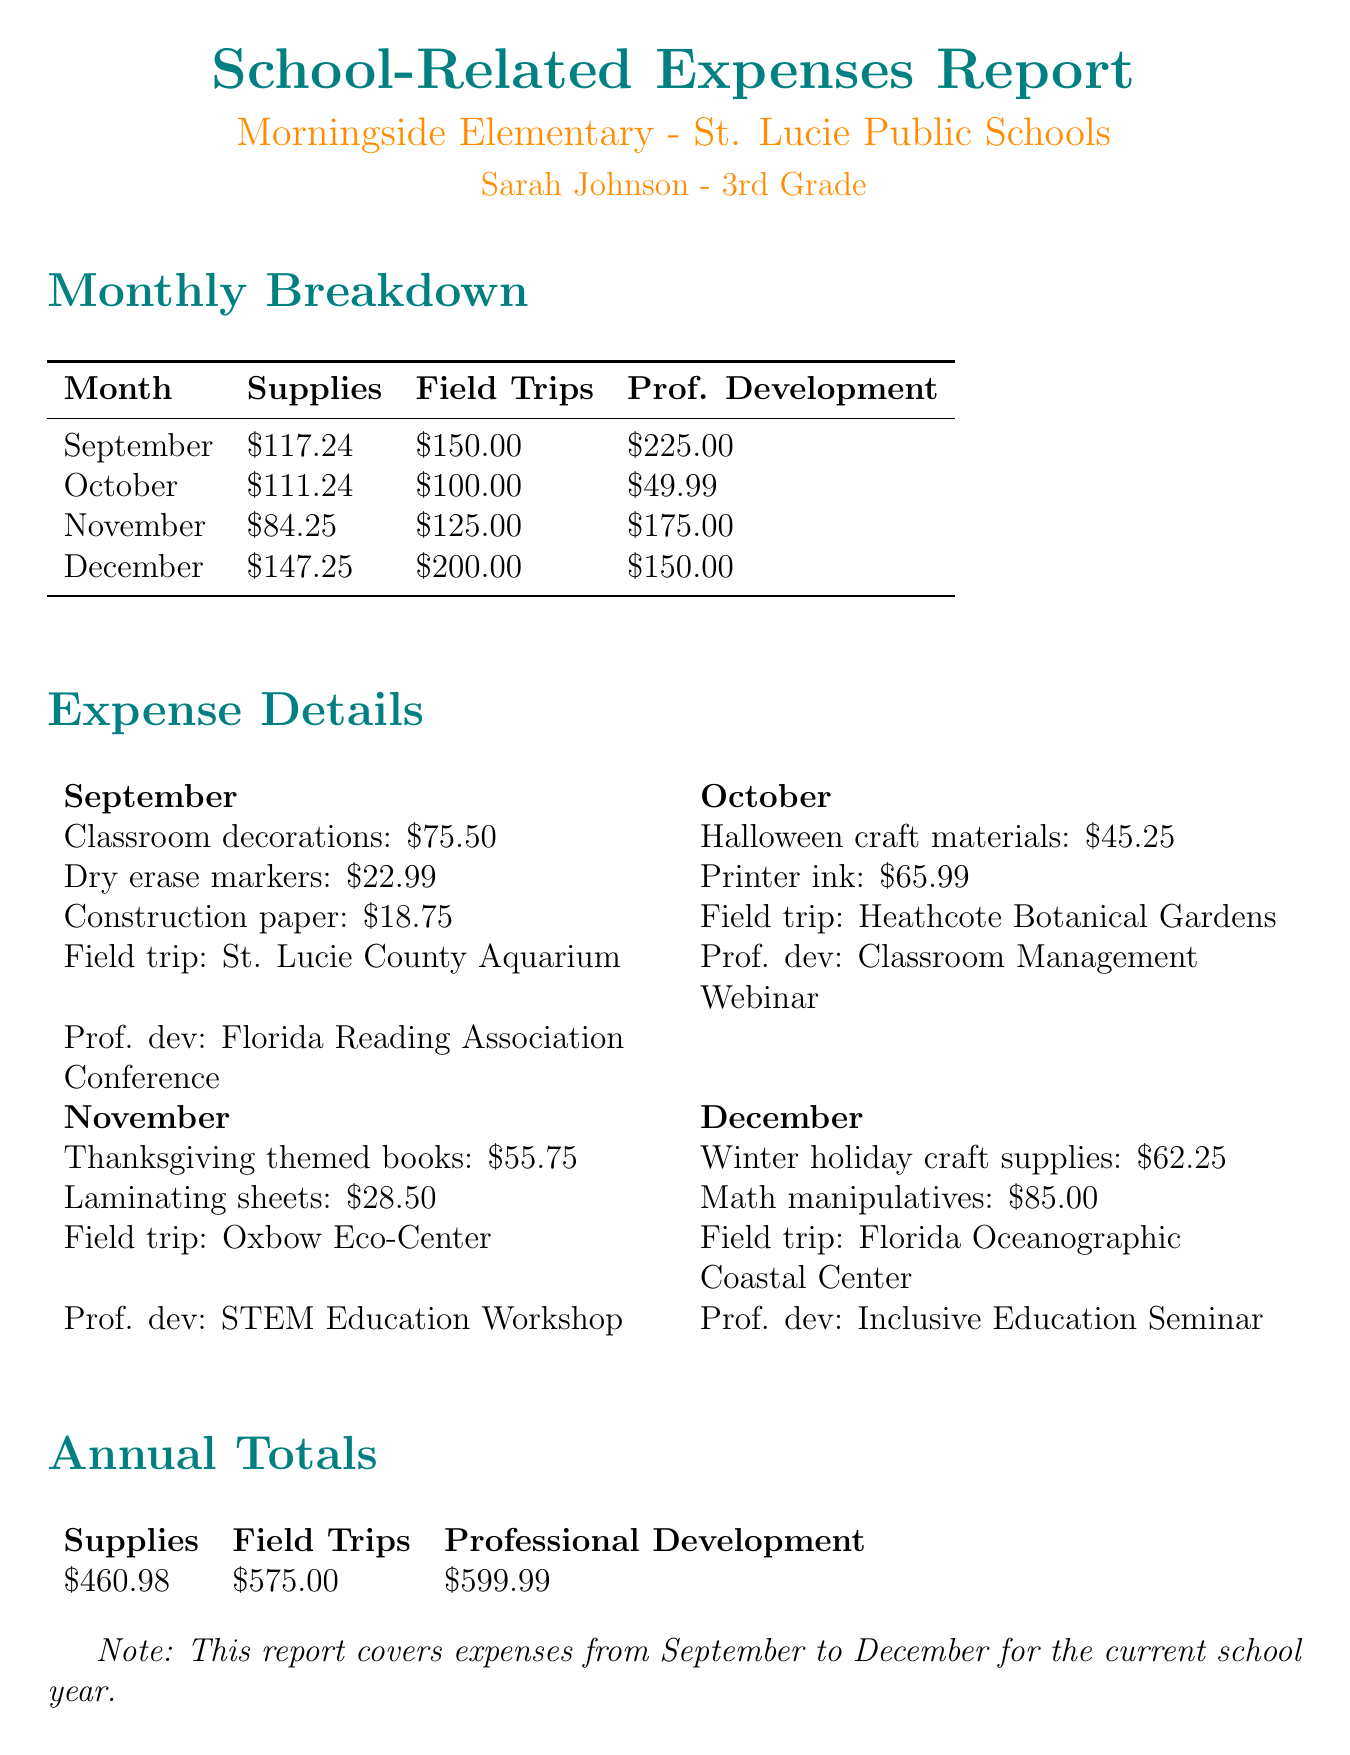What was the expense on classroom decorations in September? The expense on classroom decorations is listed in the September supplies section, which shows $75.50.
Answer: $75.50 How much was spent on field trips in November? The field trips section for November shows a total expense of $125.00.
Answer: $125.00 What is the total amount spent on professional development across all months? The annual totals section lists the total amount spent on professional development as $599.99.
Answer: $599.99 Which professional development event occurred in October? The document specifies that the Classroom Management Webinar occurred in October.
Answer: Classroom Management Webinar In which month did the highest total expense occur? By comparing the total expenses per month, December had the highest total expense of $502.25.
Answer: December What were the total supplies expenses for the month of October? The supplies total for October adds up to $111.24 as reflected in the monthly breakdown.
Answer: $111.24 Which school is this report for? The report clearly states that it is for Morningside Elementary.
Answer: Morningside Elementary What is the total expense for field trips from September to December? The annual totals section shows that the total expense for field trips is $575.00.
Answer: $575.00 What is included in the professional development costs for December? The professional development costs for December include the Inclusive Education Seminar, totaling $150.00.
Answer: Inclusive Education Seminar 